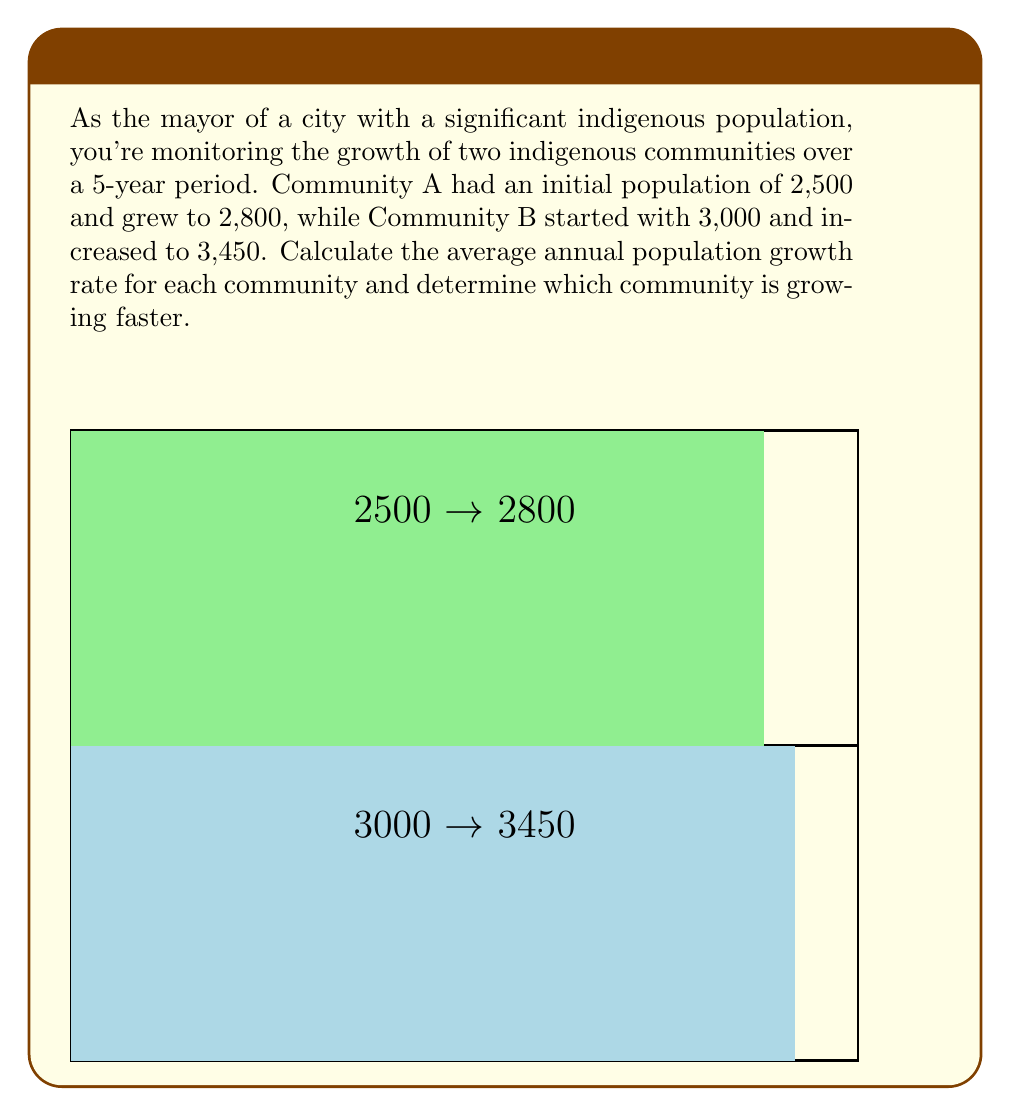Can you answer this question? To calculate the average annual population growth rate, we'll use the compound annual growth rate (CAGR) formula:

$$ CAGR = \left(\frac{Ending Value}{Beginning Value}\right)^{\frac{1}{n}} - 1 $$

Where $n$ is the number of years.

For Community A:
$$ CAGR_A = \left(\frac{2800}{2500}\right)^{\frac{1}{5}} - 1 $$
$$ = (1.12)^{0.2} - 1 $$
$$ = 1.0229 - 1 $$
$$ = 0.0229 = 2.29\% $$

For Community B:
$$ CAGR_B = \left(\frac{3450}{3000}\right)^{\frac{1}{5}} - 1 $$
$$ = (1.15)^{0.2} - 1 $$
$$ = 1.0283 - 1 $$
$$ = 0.0283 = 2.83\% $$

Community B has a higher average annual growth rate (2.83%) compared to Community A (2.29%), so Community B is growing faster.
Answer: Community A: 2.29%, Community B: 2.83%; Community B is growing faster. 